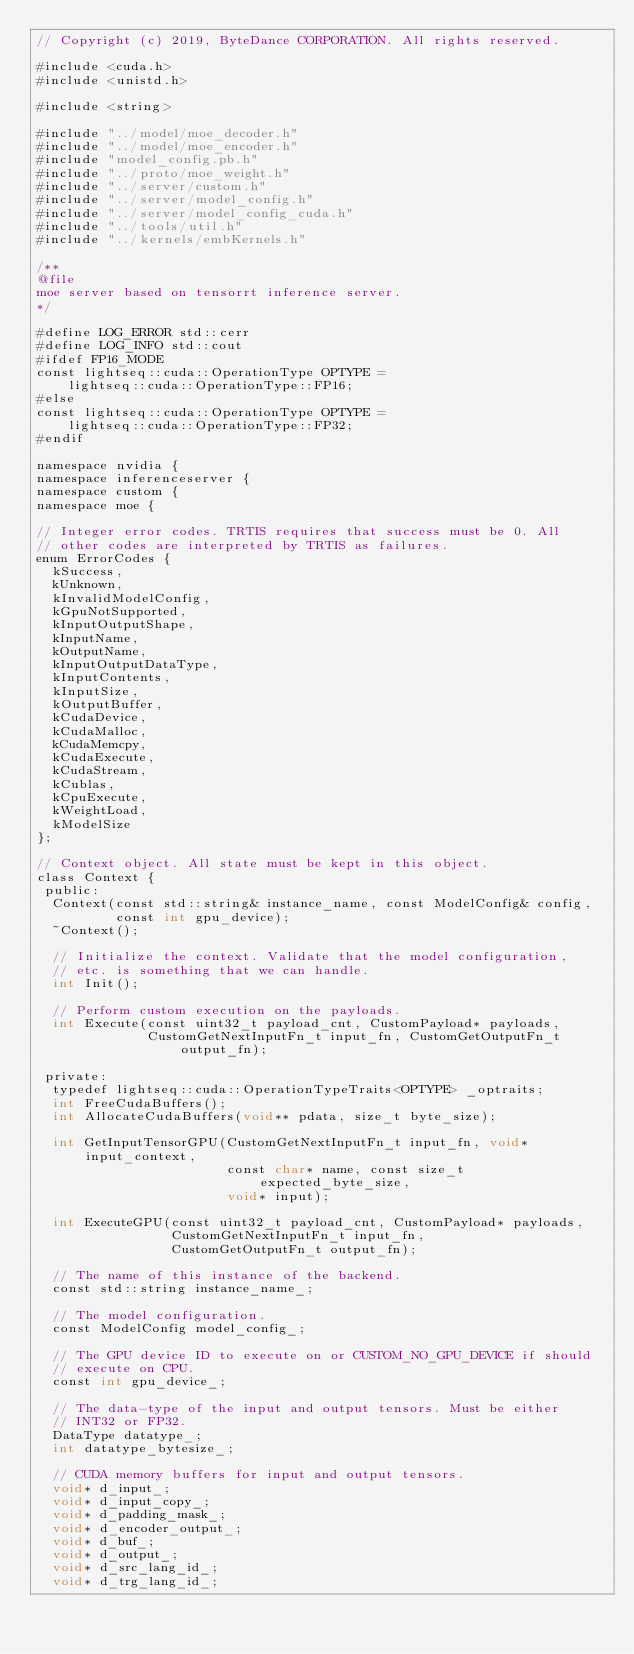<code> <loc_0><loc_0><loc_500><loc_500><_Cuda_>// Copyright (c) 2019, ByteDance CORPORATION. All rights reserved.

#include <cuda.h>
#include <unistd.h>

#include <string>

#include "../model/moe_decoder.h"
#include "../model/moe_encoder.h"
#include "model_config.pb.h"
#include "../proto/moe_weight.h"
#include "../server/custom.h"
#include "../server/model_config.h"
#include "../server/model_config_cuda.h"
#include "../tools/util.h"
#include "../kernels/embKernels.h"

/**
@file
moe server based on tensorrt inference server.
*/

#define LOG_ERROR std::cerr
#define LOG_INFO std::cout
#ifdef FP16_MODE
const lightseq::cuda::OperationType OPTYPE =
    lightseq::cuda::OperationType::FP16;
#else
const lightseq::cuda::OperationType OPTYPE =
    lightseq::cuda::OperationType::FP32;
#endif

namespace nvidia {
namespace inferenceserver {
namespace custom {
namespace moe {

// Integer error codes. TRTIS requires that success must be 0. All
// other codes are interpreted by TRTIS as failures.
enum ErrorCodes {
  kSuccess,
  kUnknown,
  kInvalidModelConfig,
  kGpuNotSupported,
  kInputOutputShape,
  kInputName,
  kOutputName,
  kInputOutputDataType,
  kInputContents,
  kInputSize,
  kOutputBuffer,
  kCudaDevice,
  kCudaMalloc,
  kCudaMemcpy,
  kCudaExecute,
  kCudaStream,
  kCublas,
  kCpuExecute,
  kWeightLoad,
  kModelSize
};

// Context object. All state must be kept in this object.
class Context {
 public:
  Context(const std::string& instance_name, const ModelConfig& config,
          const int gpu_device);
  ~Context();

  // Initialize the context. Validate that the model configuration,
  // etc. is something that we can handle.
  int Init();

  // Perform custom execution on the payloads.
  int Execute(const uint32_t payload_cnt, CustomPayload* payloads,
              CustomGetNextInputFn_t input_fn, CustomGetOutputFn_t output_fn);

 private:
  typedef lightseq::cuda::OperationTypeTraits<OPTYPE> _optraits;
  int FreeCudaBuffers();
  int AllocateCudaBuffers(void** pdata, size_t byte_size);

  int GetInputTensorGPU(CustomGetNextInputFn_t input_fn, void* input_context,
                        const char* name, const size_t expected_byte_size,
                        void* input);

  int ExecuteGPU(const uint32_t payload_cnt, CustomPayload* payloads,
                 CustomGetNextInputFn_t input_fn,
                 CustomGetOutputFn_t output_fn);

  // The name of this instance of the backend.
  const std::string instance_name_;

  // The model configuration.
  const ModelConfig model_config_;

  // The GPU device ID to execute on or CUSTOM_NO_GPU_DEVICE if should
  // execute on CPU.
  const int gpu_device_;

  // The data-type of the input and output tensors. Must be either
  // INT32 or FP32.
  DataType datatype_;
  int datatype_bytesize_;

  // CUDA memory buffers for input and output tensors.
  void* d_input_;
  void* d_input_copy_;
  void* d_padding_mask_;
  void* d_encoder_output_;
  void* d_buf_;
  void* d_output_;
  void* d_src_lang_id_;
  void* d_trg_lang_id_;
</code> 